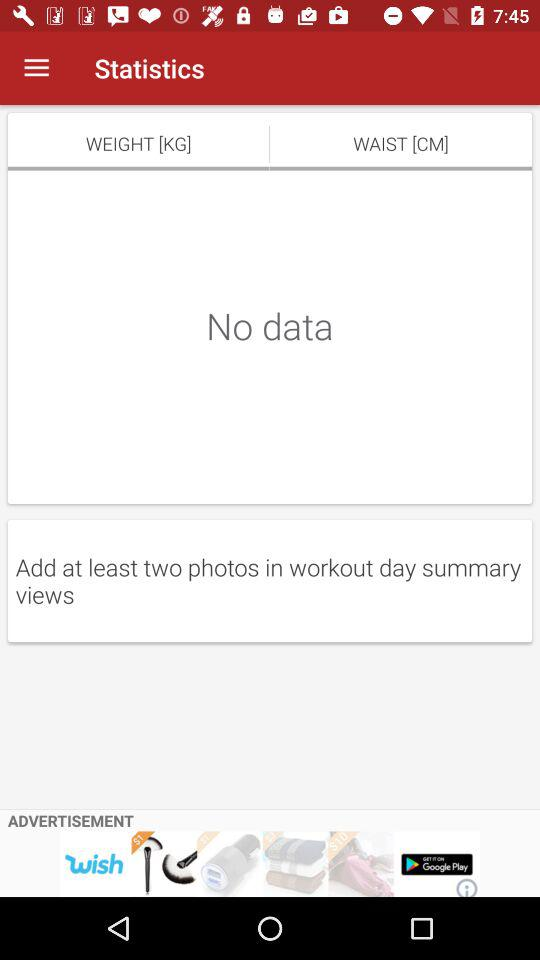What's the measurement unit of weight? The measurement unit is kg. 